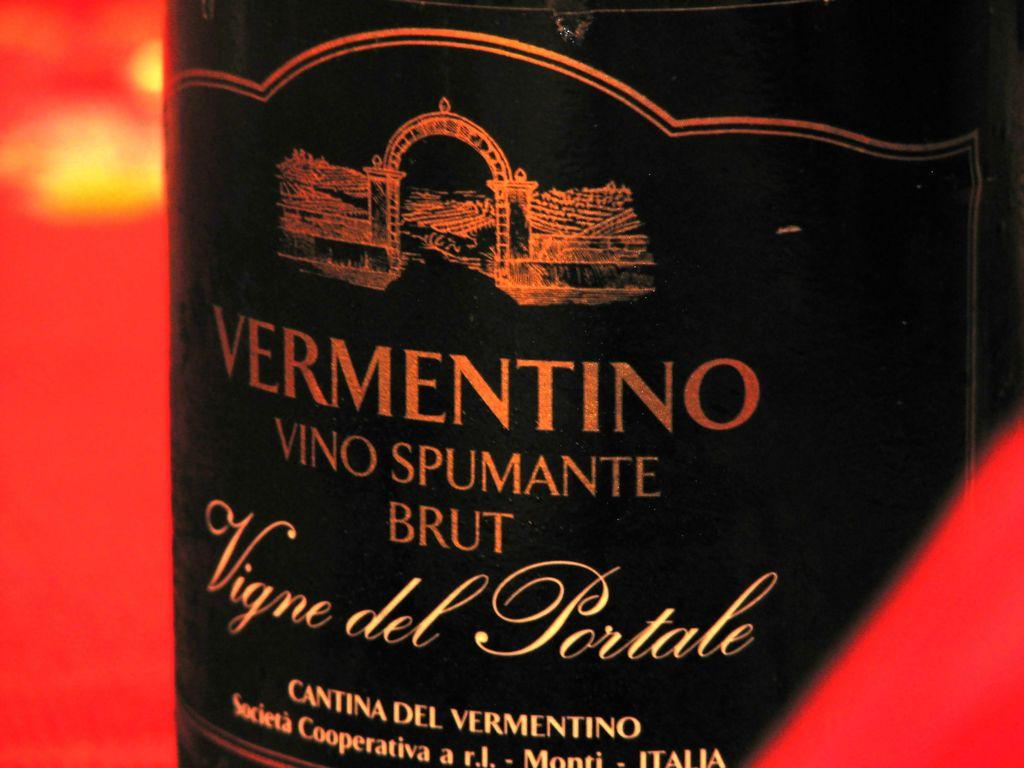<image>
Render a clear and concise summary of the photo. The label for VERMENTINO VINO SPUMANTE BRUT Vigne del Portale is shown. 